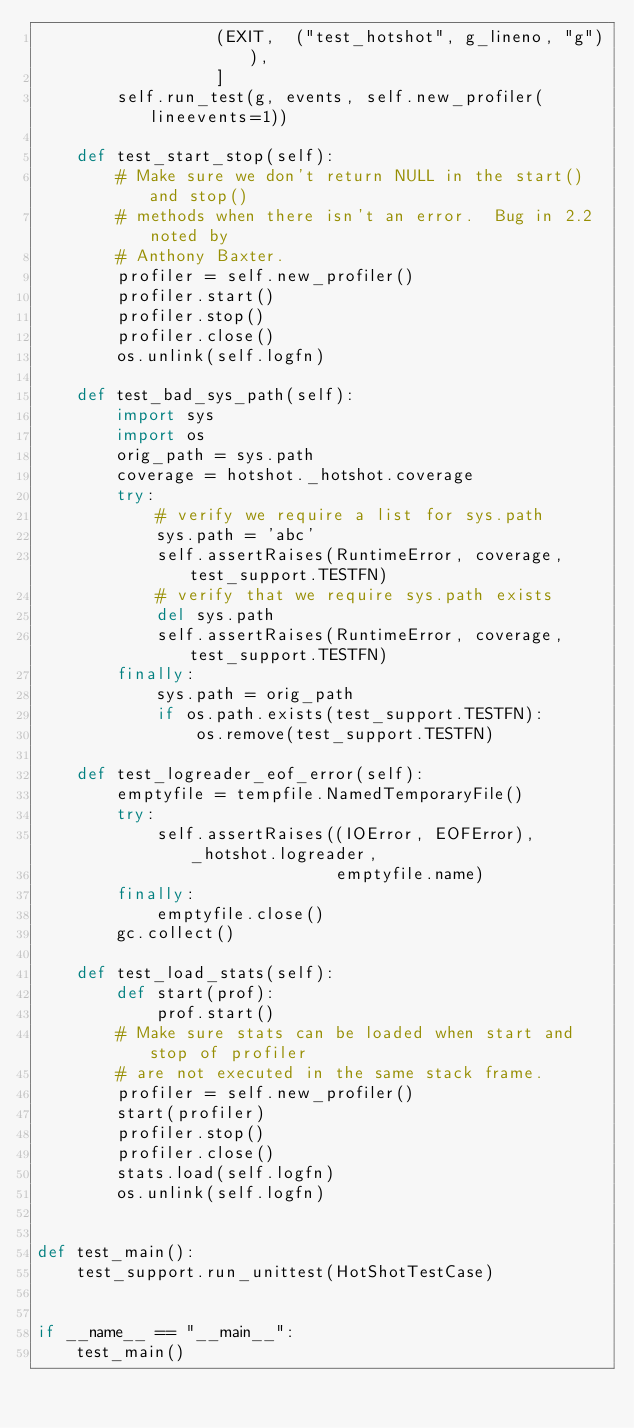<code> <loc_0><loc_0><loc_500><loc_500><_Python_>                  (EXIT,  ("test_hotshot", g_lineno, "g")),
                  ]
        self.run_test(g, events, self.new_profiler(lineevents=1))

    def test_start_stop(self):
        # Make sure we don't return NULL in the start() and stop()
        # methods when there isn't an error.  Bug in 2.2 noted by
        # Anthony Baxter.
        profiler = self.new_profiler()
        profiler.start()
        profiler.stop()
        profiler.close()
        os.unlink(self.logfn)

    def test_bad_sys_path(self):
        import sys
        import os
        orig_path = sys.path
        coverage = hotshot._hotshot.coverage
        try:
            # verify we require a list for sys.path
            sys.path = 'abc'
            self.assertRaises(RuntimeError, coverage, test_support.TESTFN)
            # verify that we require sys.path exists
            del sys.path
            self.assertRaises(RuntimeError, coverage, test_support.TESTFN)
        finally:
            sys.path = orig_path
            if os.path.exists(test_support.TESTFN):
                os.remove(test_support.TESTFN)

    def test_logreader_eof_error(self):
        emptyfile = tempfile.NamedTemporaryFile()
        try:
            self.assertRaises((IOError, EOFError), _hotshot.logreader,
                              emptyfile.name)
        finally:
            emptyfile.close()
        gc.collect()

    def test_load_stats(self):
        def start(prof):
            prof.start()
        # Make sure stats can be loaded when start and stop of profiler
        # are not executed in the same stack frame.
        profiler = self.new_profiler()
        start(profiler)
        profiler.stop()
        profiler.close()
        stats.load(self.logfn)
        os.unlink(self.logfn)


def test_main():
    test_support.run_unittest(HotShotTestCase)


if __name__ == "__main__":
    test_main()
</code> 